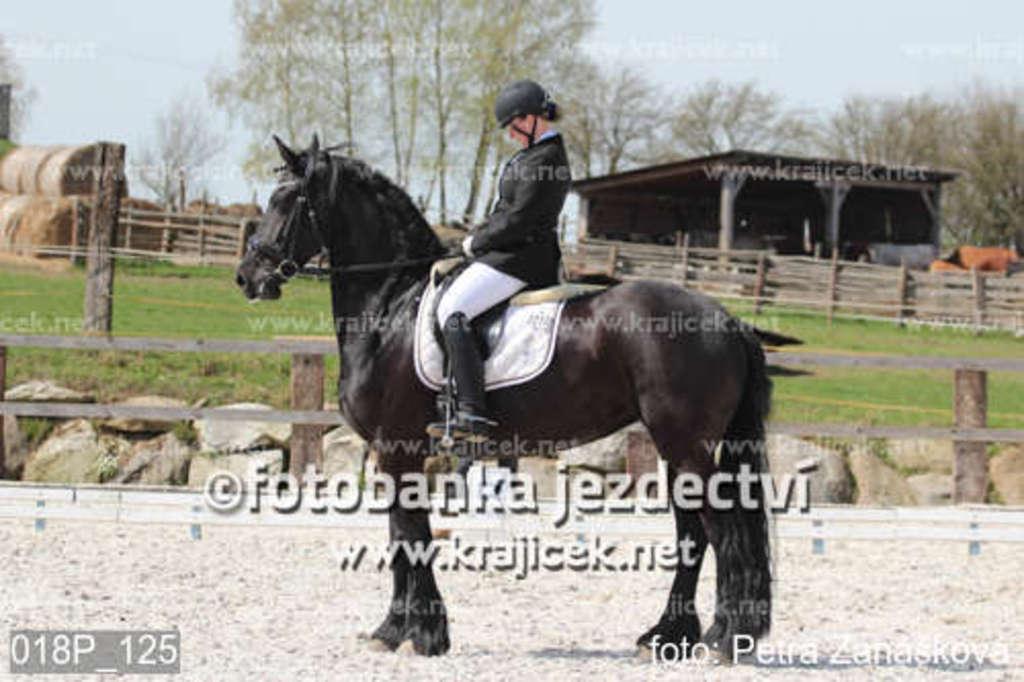How would you summarize this image in a sentence or two? There is a man sitting on the horse wearing a helmet on the ground. Behind him there is a railing. In the background there is a shed, grass and trees and a sky here. 